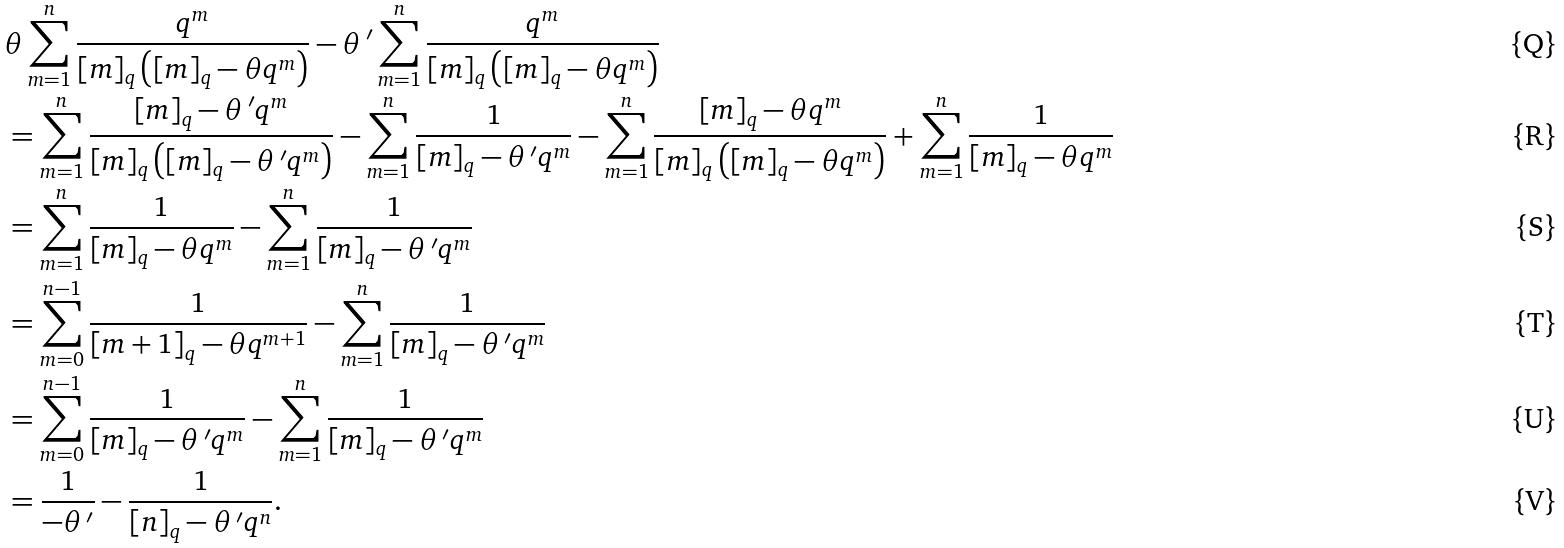Convert formula to latex. <formula><loc_0><loc_0><loc_500><loc_500>& \theta \sum _ { m = 1 } ^ { n } \frac { q ^ { m } } { [ m ] _ { q } \left ( [ m ] _ { q } - \theta q ^ { m } \right ) } - \theta \, ^ { \prime } \sum _ { m = 1 } ^ { n } \frac { q ^ { m } } { [ m ] _ { q } \left ( [ m ] _ { q } - \theta q ^ { m } \right ) } \\ & = \sum _ { m = 1 } ^ { n } \frac { [ m ] _ { q } - \theta \, ^ { \prime } q ^ { m } } { [ m ] _ { q } \left ( [ m ] _ { q } - \theta \, ^ { \prime } q ^ { m } \right ) } - \sum _ { m = 1 } ^ { n } \frac { 1 } { [ m ] _ { q } - \theta \, ^ { \prime } q ^ { m } } - \sum _ { m = 1 } ^ { n } \frac { [ m ] _ { q } - \theta q ^ { m } } { [ m ] _ { q } \left ( [ m ] _ { q } - \theta q ^ { m } \right ) } + \sum _ { m = 1 } ^ { n } \frac { 1 } { [ m ] _ { q } - \theta q ^ { m } } \\ & = \sum _ { m = 1 } ^ { n } \frac { 1 } { [ m ] _ { q } - \theta q ^ { m } } - \sum _ { m = 1 } ^ { n } \frac { 1 } { [ m ] _ { q } - \theta \, ^ { \prime } q ^ { m } } \\ & = \sum _ { m = 0 } ^ { n - 1 } \frac { 1 } { [ m + 1 ] _ { q } - \theta q ^ { m + 1 } } - \sum _ { m = 1 } ^ { n } \frac { 1 } { [ m ] _ { q } - \theta \, ^ { \prime } q ^ { m } } \\ & = \sum _ { m = 0 } ^ { n - 1 } \frac { 1 } { [ m ] _ { q } - \theta \, ^ { \prime } q ^ { m } } - \sum _ { m = 1 } ^ { n } \frac { 1 } { [ m ] _ { q } - \theta \, ^ { \prime } q ^ { m } } \\ & = \frac { 1 } { - \theta \, ^ { \prime } } - \frac { 1 } { [ n ] _ { q } - \theta \, ^ { \prime } q ^ { n } } .</formula> 